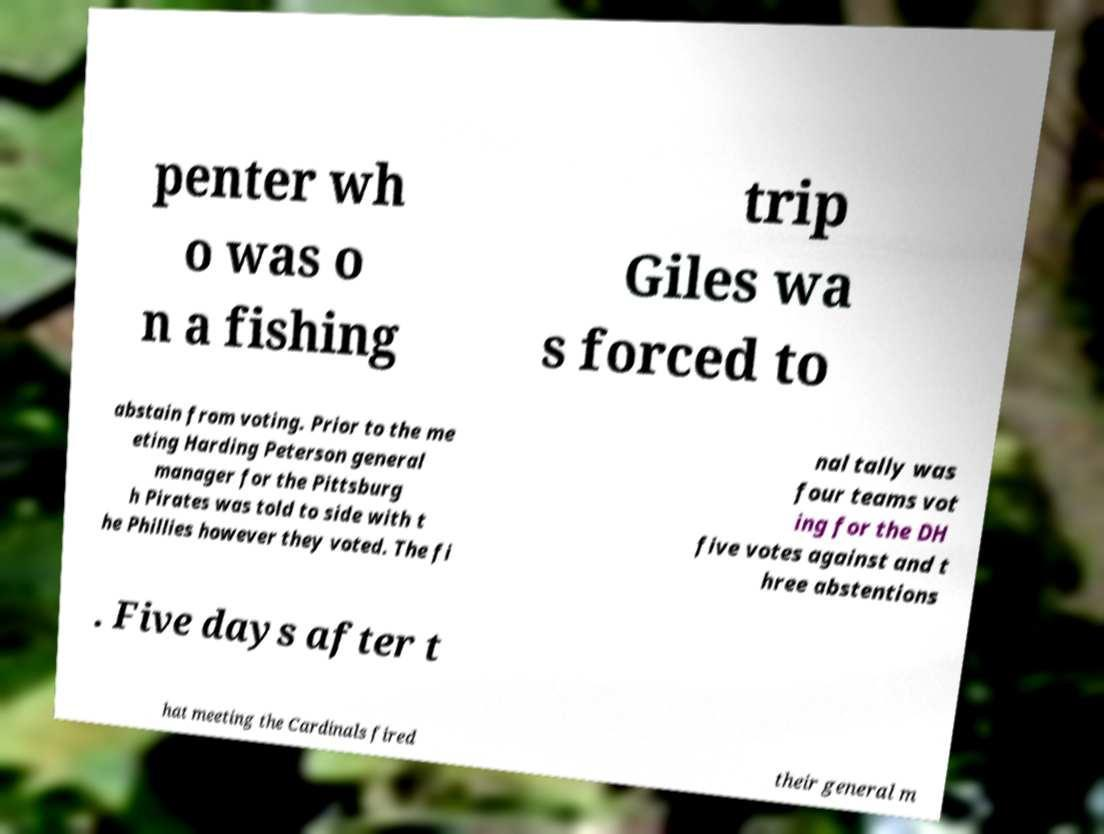There's text embedded in this image that I need extracted. Can you transcribe it verbatim? penter wh o was o n a fishing trip Giles wa s forced to abstain from voting. Prior to the me eting Harding Peterson general manager for the Pittsburg h Pirates was told to side with t he Phillies however they voted. The fi nal tally was four teams vot ing for the DH five votes against and t hree abstentions . Five days after t hat meeting the Cardinals fired their general m 